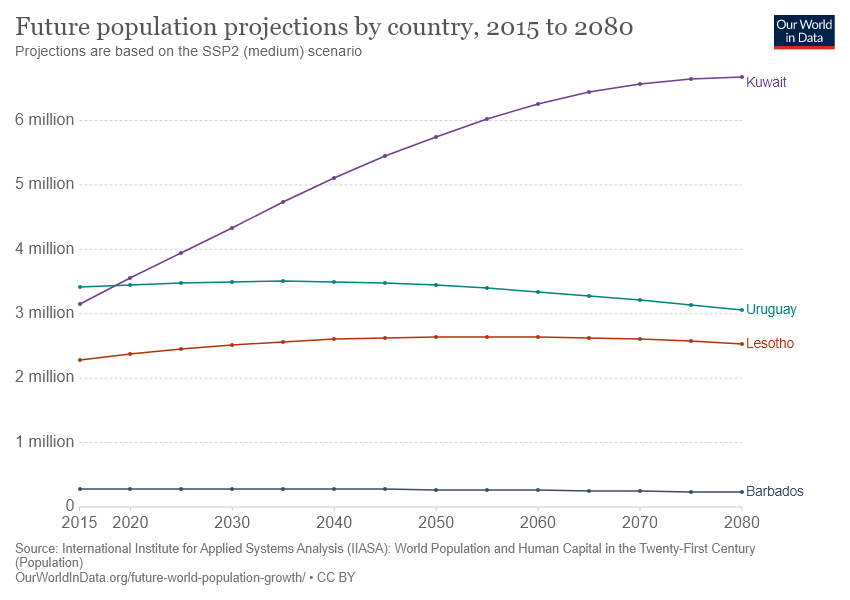Outline some significant characteristics in this image. According to the latest population projection, Barbados is expected to have the lowest future population growth rate among all countries. In 2020, the population projection for Kuwait exceeded Uruguay. 